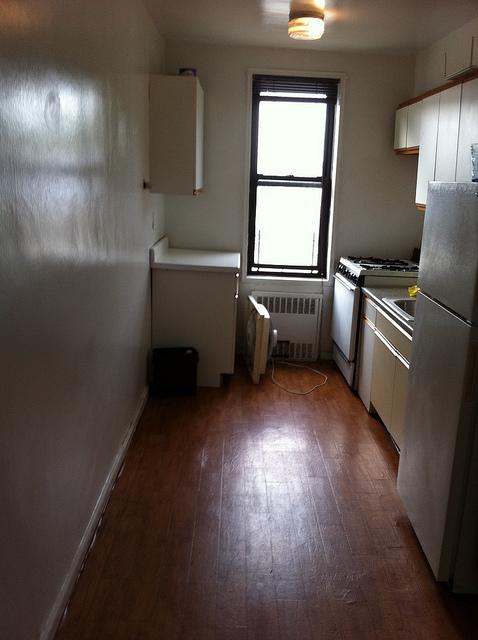Is the light on?
Give a very brief answer. Yes. What room is this?
Quick response, please. Kitchen. Is the floor wood?
Quick response, please. Yes. 